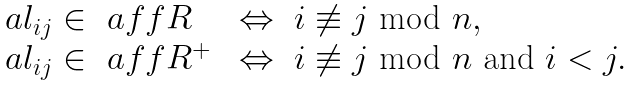<formula> <loc_0><loc_0><loc_500><loc_500>\begin{array} { l l } \ a l _ { i j } \in \ a f f R \ & \Leftrightarrow \ i \not \equiv j \text { mod } n , \\ \ a l _ { i j } \in \ a f f R ^ { + } \ & \Leftrightarrow \ i \not \equiv j \text { mod } n \text { and } i < j . \end{array}</formula> 